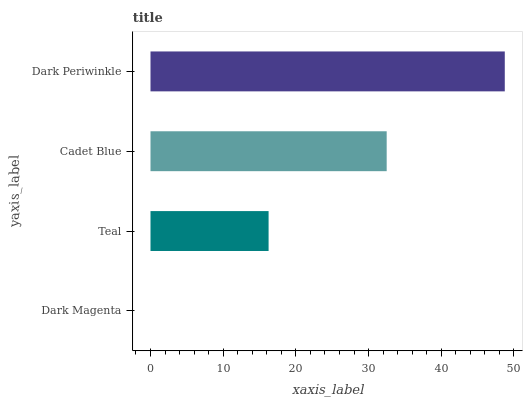Is Dark Magenta the minimum?
Answer yes or no. Yes. Is Dark Periwinkle the maximum?
Answer yes or no. Yes. Is Teal the minimum?
Answer yes or no. No. Is Teal the maximum?
Answer yes or no. No. Is Teal greater than Dark Magenta?
Answer yes or no. Yes. Is Dark Magenta less than Teal?
Answer yes or no. Yes. Is Dark Magenta greater than Teal?
Answer yes or no. No. Is Teal less than Dark Magenta?
Answer yes or no. No. Is Cadet Blue the high median?
Answer yes or no. Yes. Is Teal the low median?
Answer yes or no. Yes. Is Dark Periwinkle the high median?
Answer yes or no. No. Is Dark Magenta the low median?
Answer yes or no. No. 